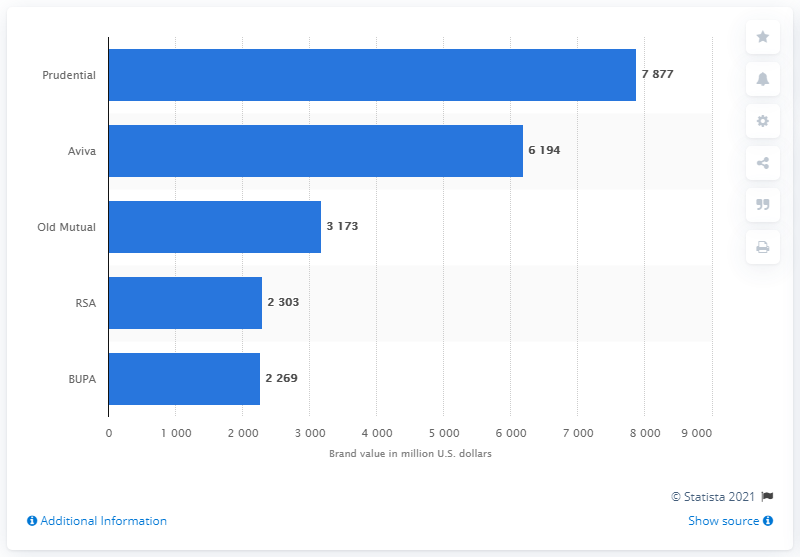Point out several critical features in this image. As of June 2015, Prudential was ranked first among all insurance companies operating in the United Kingdom. Prudential's brand value, as of the given date, was approximately 7,877 US dollars. 